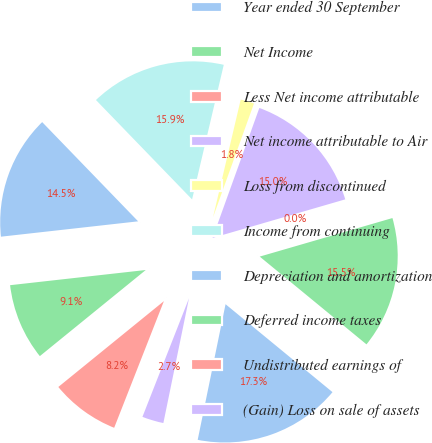Convert chart to OTSL. <chart><loc_0><loc_0><loc_500><loc_500><pie_chart><fcel>Year ended 30 September<fcel>Net Income<fcel>Less Net income attributable<fcel>Net income attributable to Air<fcel>Loss from discontinued<fcel>Income from continuing<fcel>Depreciation and amortization<fcel>Deferred income taxes<fcel>Undistributed earnings of<fcel>(Gain) Loss on sale of assets<nl><fcel>17.27%<fcel>15.45%<fcel>0.0%<fcel>15.0%<fcel>1.82%<fcel>15.91%<fcel>14.54%<fcel>9.09%<fcel>8.18%<fcel>2.73%<nl></chart> 